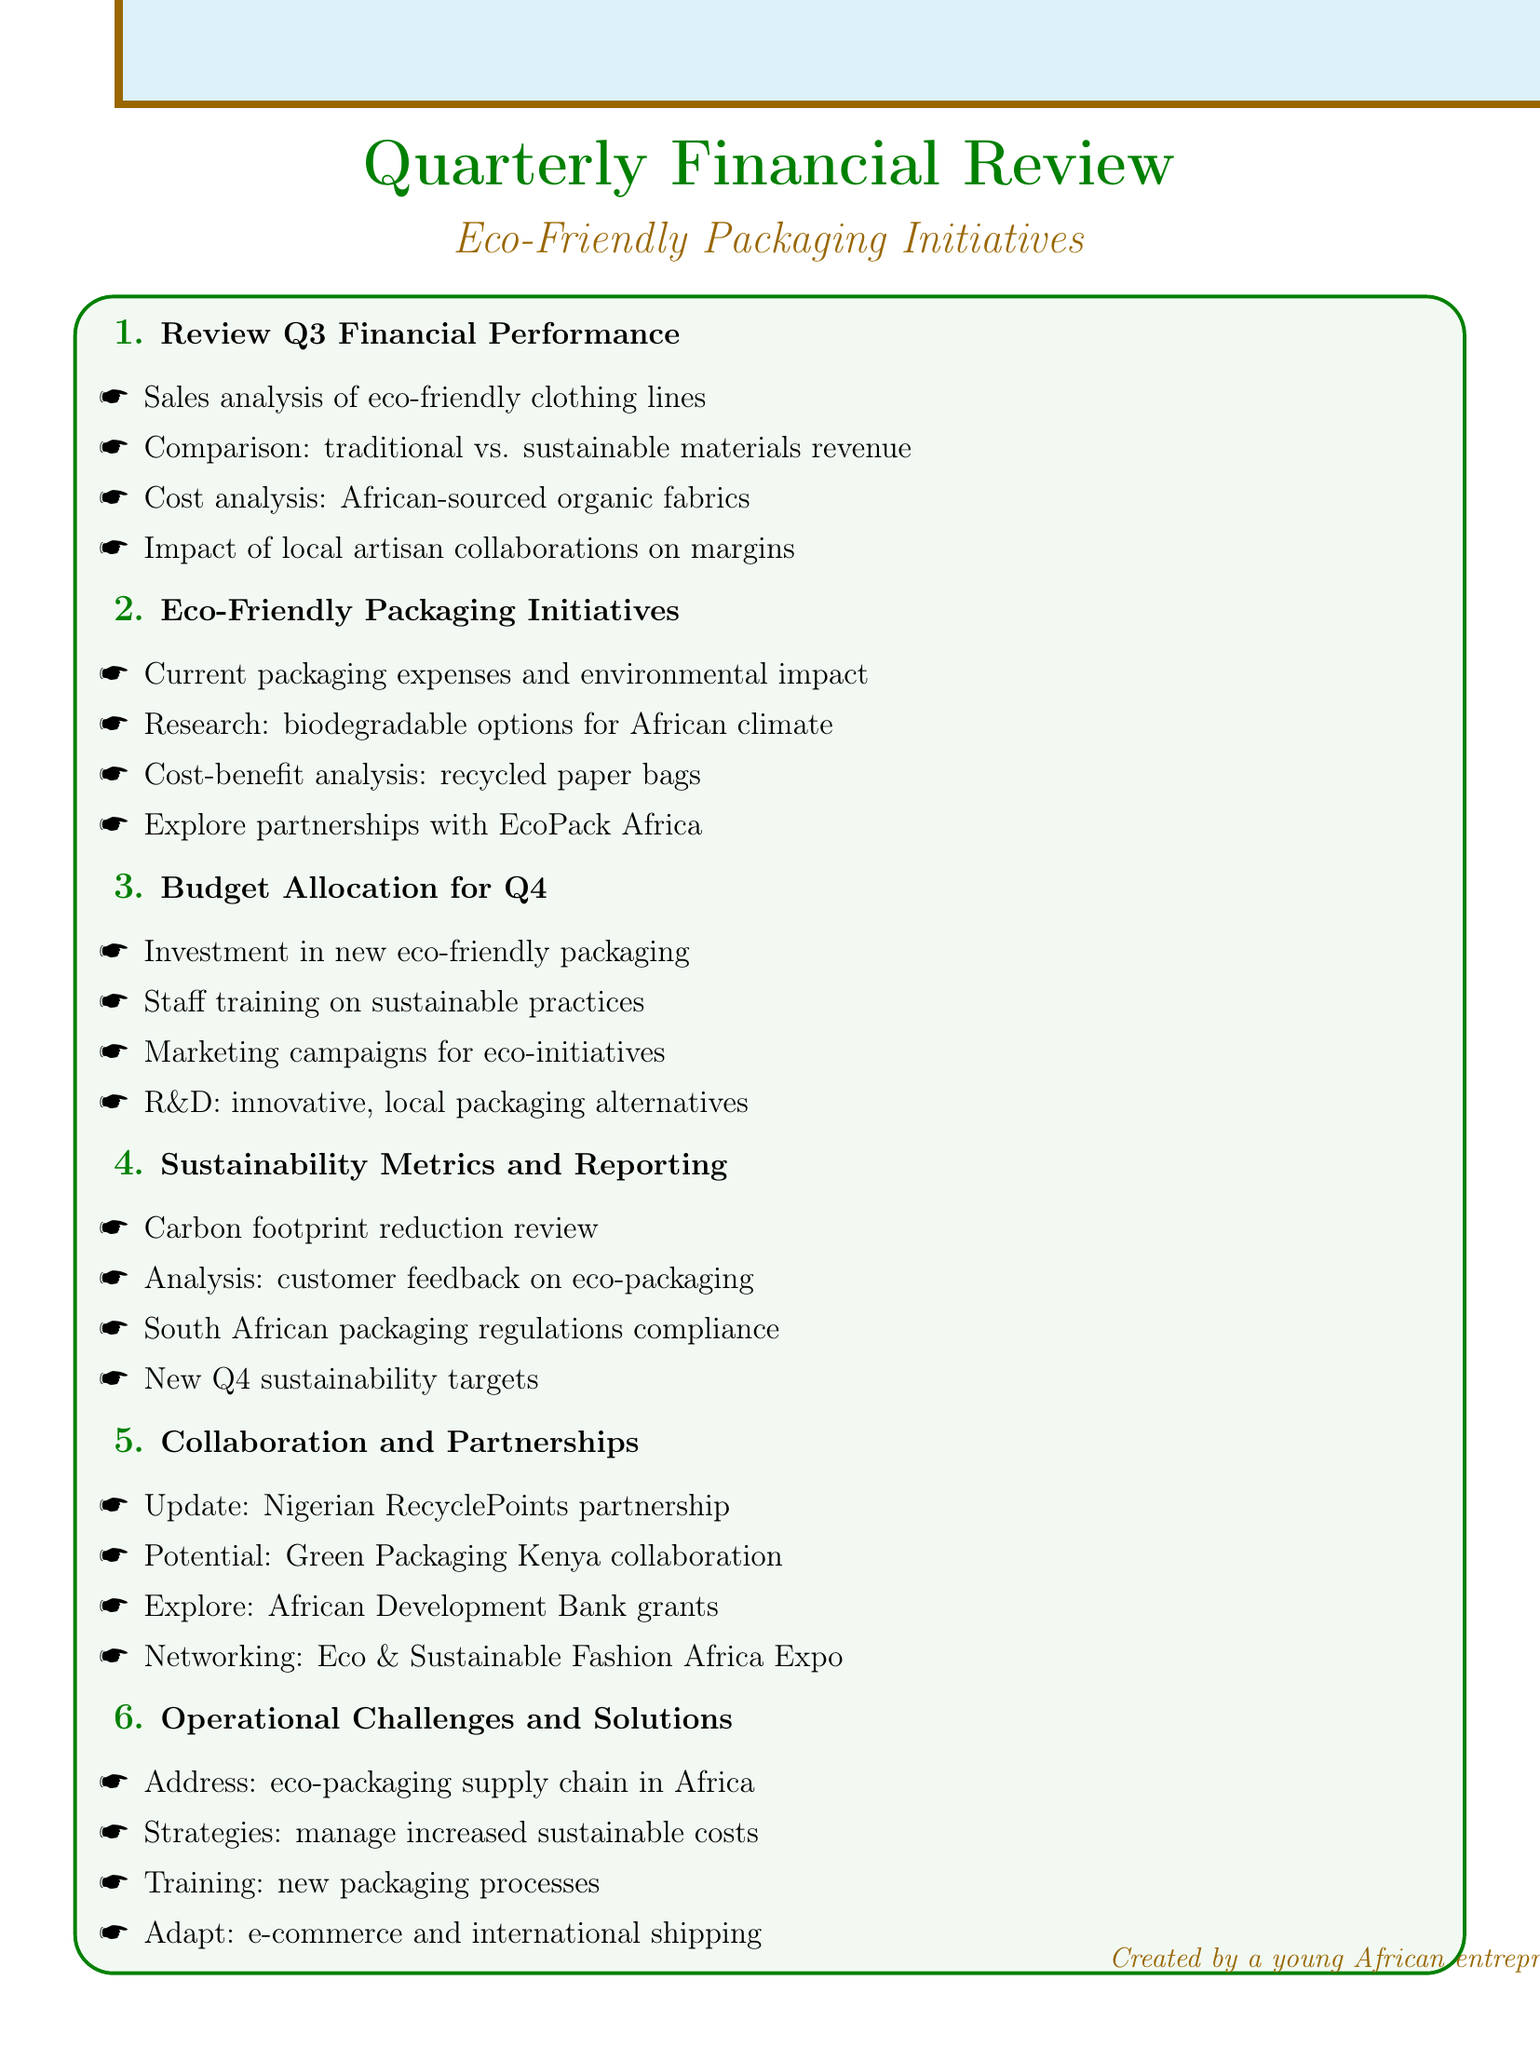What is the total number of agenda items? The document lists a total of six agenda items related to the quarterly financial review and eco-friendly initiatives.
Answer: 6 Who is responsible for the update on the partnership with RecyclePoints? The agenda item refers to collaboration and partnerships, specifically mentioning an update on the partnership with the Nigerian recycling startup RecyclePoints.
Answer: RecyclePoints What is one of the proposed investments for Q4? The budget allocation for Q4 includes a proposed investment specifically targeting new eco-friendly packaging materials.
Answer: New eco-friendly packaging materials Which organization is mentioned for exploring grants? In the collaboration and partnerships section, the African Development Bank's Sustainable Energy Fund for Africa is identified as a potential source for exploring grants.
Answer: African Development Bank What does the sustainability metrics section analyze? The agenda under sustainability metrics and reporting includes an analysis of customer feedback on eco-friendly packaging as one of its points.
Answer: Customer feedback on eco-friendly packaging What is the focus of the cost-benefit analysis discussed? The eco-friendly packaging initiatives mention a cost-benefit analysis specifically related to switching to recycled paper bags.
Answer: Recycled paper bags 